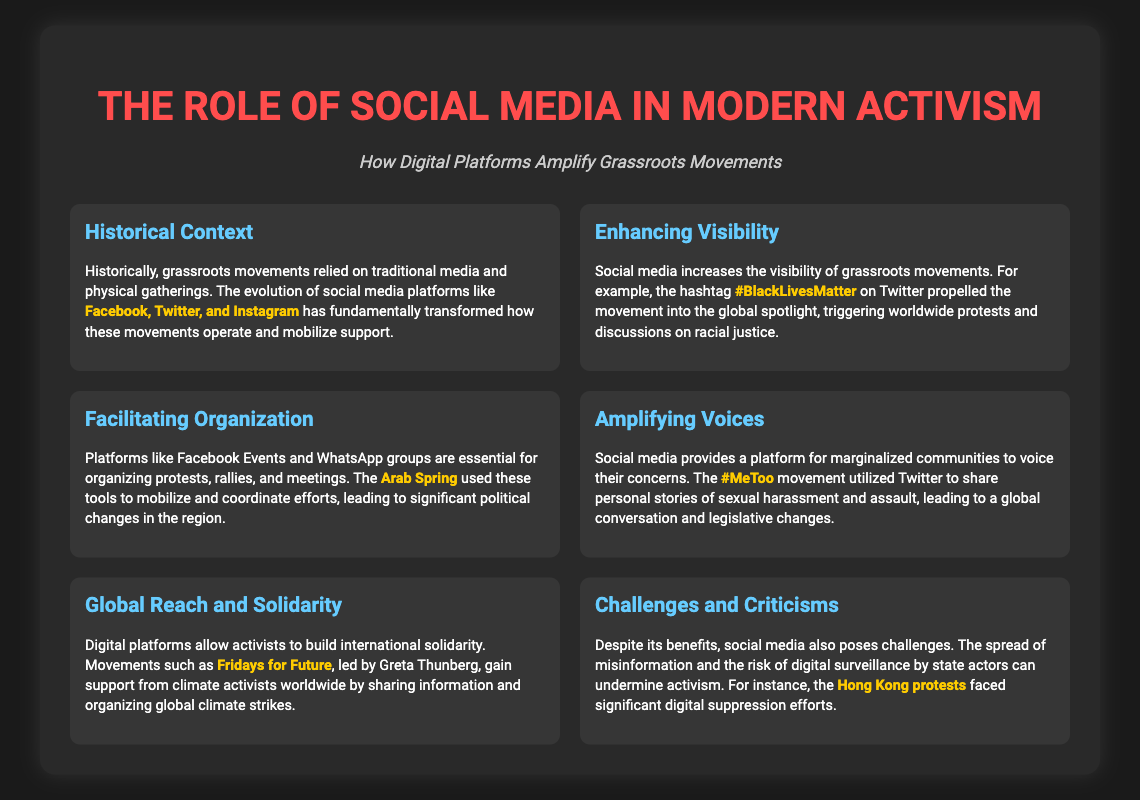What is the title of the presentation? The title of the presentation is displayed prominently at the top of the slide.
Answer: The Role of Social Media in Modern Activism Which hashtag increased visibility for the racial justice movement? The presentation specifically mentions a hashtag that propelled the movement into the global spotlight.
Answer: #BlackLivesMatter What movement utilized Facebook Events for organization? The text cites a specific regional event that used these tools for mobilization.
Answer: Arab Spring What is a major platform for sharing stories in the #MeToo movement? The presentation references a particular social media platform that was significant for this movement.
Answer: Twitter Who led the Fridays for Future movement? The slide provides information on the leader of this global climate activist initiative.
Answer: Greta Thunberg What is a challenge posed by social media in activism? The document briefly outlines one major downside related to social media's influence on activism.
Answer: Misinformation What is one significant event mentioned related to digital surveillance? The slide discusses a particular protest that faced challenges due to digital suppression.
Answer: Hong Kong protests 